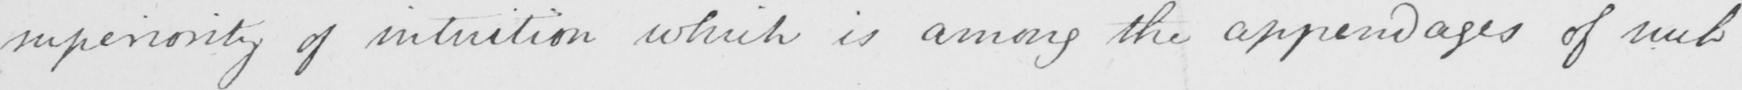Can you tell me what this handwritten text says? superiority of intuition which is among the appendages of such 